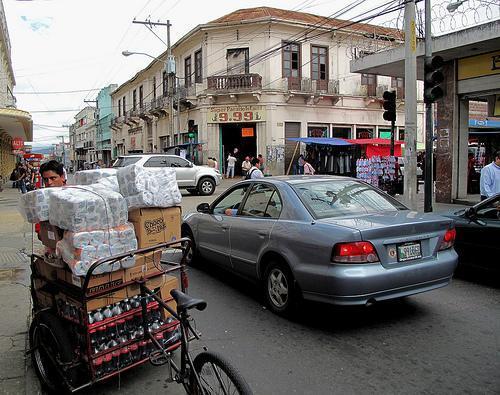How many cars are there?
Give a very brief answer. 3. How many people are getting on bus?
Give a very brief answer. 0. 